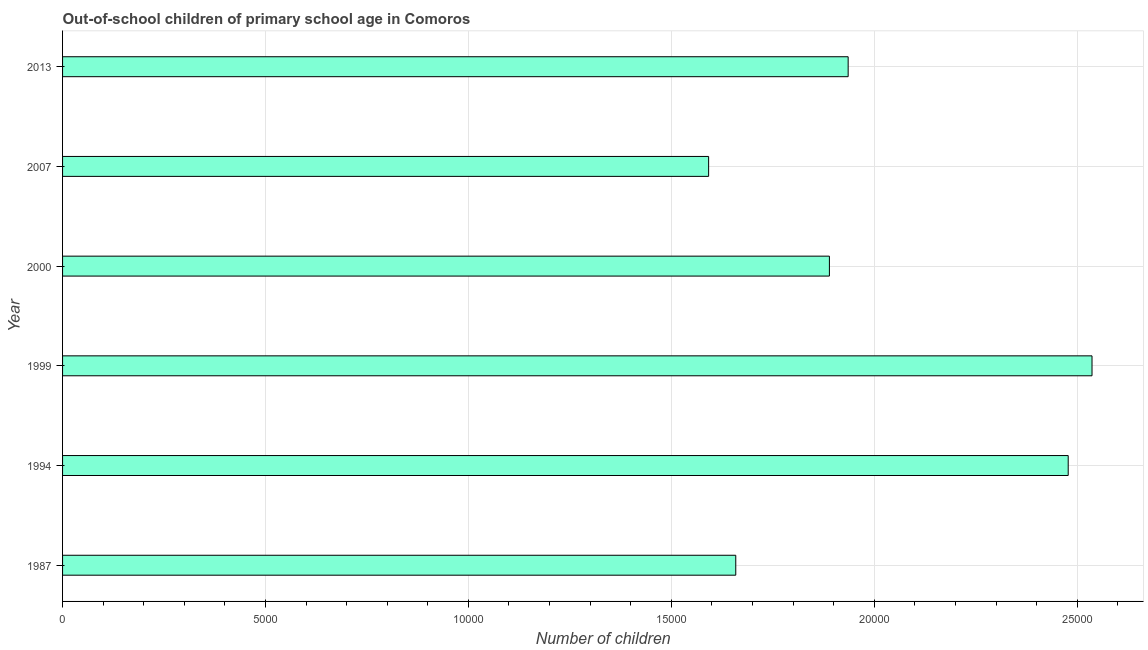What is the title of the graph?
Give a very brief answer. Out-of-school children of primary school age in Comoros. What is the label or title of the X-axis?
Give a very brief answer. Number of children. What is the label or title of the Y-axis?
Ensure brevity in your answer.  Year. What is the number of out-of-school children in 1999?
Your answer should be compact. 2.54e+04. Across all years, what is the maximum number of out-of-school children?
Offer a terse response. 2.54e+04. Across all years, what is the minimum number of out-of-school children?
Provide a short and direct response. 1.59e+04. In which year was the number of out-of-school children minimum?
Offer a terse response. 2007. What is the sum of the number of out-of-school children?
Your answer should be compact. 1.21e+05. What is the difference between the number of out-of-school children in 1994 and 2000?
Offer a very short reply. 5884. What is the average number of out-of-school children per year?
Provide a short and direct response. 2.02e+04. What is the median number of out-of-school children?
Provide a short and direct response. 1.91e+04. Do a majority of the years between 2007 and 2013 (inclusive) have number of out-of-school children greater than 21000 ?
Your answer should be very brief. No. What is the ratio of the number of out-of-school children in 1987 to that in 2013?
Provide a succinct answer. 0.86. Is the number of out-of-school children in 1987 less than that in 1999?
Your response must be concise. Yes. Is the difference between the number of out-of-school children in 2000 and 2013 greater than the difference between any two years?
Your answer should be compact. No. What is the difference between the highest and the second highest number of out-of-school children?
Offer a very short reply. 587. What is the difference between the highest and the lowest number of out-of-school children?
Keep it short and to the point. 9447. How many bars are there?
Offer a terse response. 6. Are all the bars in the graph horizontal?
Make the answer very short. Yes. What is the difference between two consecutive major ticks on the X-axis?
Ensure brevity in your answer.  5000. Are the values on the major ticks of X-axis written in scientific E-notation?
Make the answer very short. No. What is the Number of children in 1987?
Your answer should be compact. 1.66e+04. What is the Number of children in 1994?
Provide a succinct answer. 2.48e+04. What is the Number of children in 1999?
Give a very brief answer. 2.54e+04. What is the Number of children of 2000?
Your response must be concise. 1.89e+04. What is the Number of children in 2007?
Offer a terse response. 1.59e+04. What is the Number of children in 2013?
Provide a succinct answer. 1.94e+04. What is the difference between the Number of children in 1987 and 1994?
Offer a very short reply. -8191. What is the difference between the Number of children in 1987 and 1999?
Provide a short and direct response. -8778. What is the difference between the Number of children in 1987 and 2000?
Your answer should be compact. -2307. What is the difference between the Number of children in 1987 and 2007?
Offer a terse response. 669. What is the difference between the Number of children in 1987 and 2013?
Make the answer very short. -2769. What is the difference between the Number of children in 1994 and 1999?
Your answer should be compact. -587. What is the difference between the Number of children in 1994 and 2000?
Your response must be concise. 5884. What is the difference between the Number of children in 1994 and 2007?
Your response must be concise. 8860. What is the difference between the Number of children in 1994 and 2013?
Offer a terse response. 5422. What is the difference between the Number of children in 1999 and 2000?
Ensure brevity in your answer.  6471. What is the difference between the Number of children in 1999 and 2007?
Offer a terse response. 9447. What is the difference between the Number of children in 1999 and 2013?
Make the answer very short. 6009. What is the difference between the Number of children in 2000 and 2007?
Your answer should be compact. 2976. What is the difference between the Number of children in 2000 and 2013?
Offer a terse response. -462. What is the difference between the Number of children in 2007 and 2013?
Your response must be concise. -3438. What is the ratio of the Number of children in 1987 to that in 1994?
Your response must be concise. 0.67. What is the ratio of the Number of children in 1987 to that in 1999?
Ensure brevity in your answer.  0.65. What is the ratio of the Number of children in 1987 to that in 2000?
Give a very brief answer. 0.88. What is the ratio of the Number of children in 1987 to that in 2007?
Offer a very short reply. 1.04. What is the ratio of the Number of children in 1987 to that in 2013?
Offer a very short reply. 0.86. What is the ratio of the Number of children in 1994 to that in 1999?
Keep it short and to the point. 0.98. What is the ratio of the Number of children in 1994 to that in 2000?
Your answer should be compact. 1.31. What is the ratio of the Number of children in 1994 to that in 2007?
Keep it short and to the point. 1.56. What is the ratio of the Number of children in 1994 to that in 2013?
Ensure brevity in your answer.  1.28. What is the ratio of the Number of children in 1999 to that in 2000?
Give a very brief answer. 1.34. What is the ratio of the Number of children in 1999 to that in 2007?
Offer a terse response. 1.59. What is the ratio of the Number of children in 1999 to that in 2013?
Your answer should be compact. 1.31. What is the ratio of the Number of children in 2000 to that in 2007?
Provide a short and direct response. 1.19. What is the ratio of the Number of children in 2000 to that in 2013?
Provide a short and direct response. 0.98. What is the ratio of the Number of children in 2007 to that in 2013?
Offer a terse response. 0.82. 